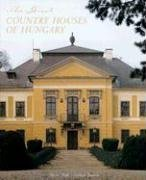Is this book related to Travel? Absolutely, 'The Great Country Houses of Hungary' is intimately connected to travel, serving as a gateway for readers to embark on a journey to discover Hungary's architectural treasures and their storied pasts. 